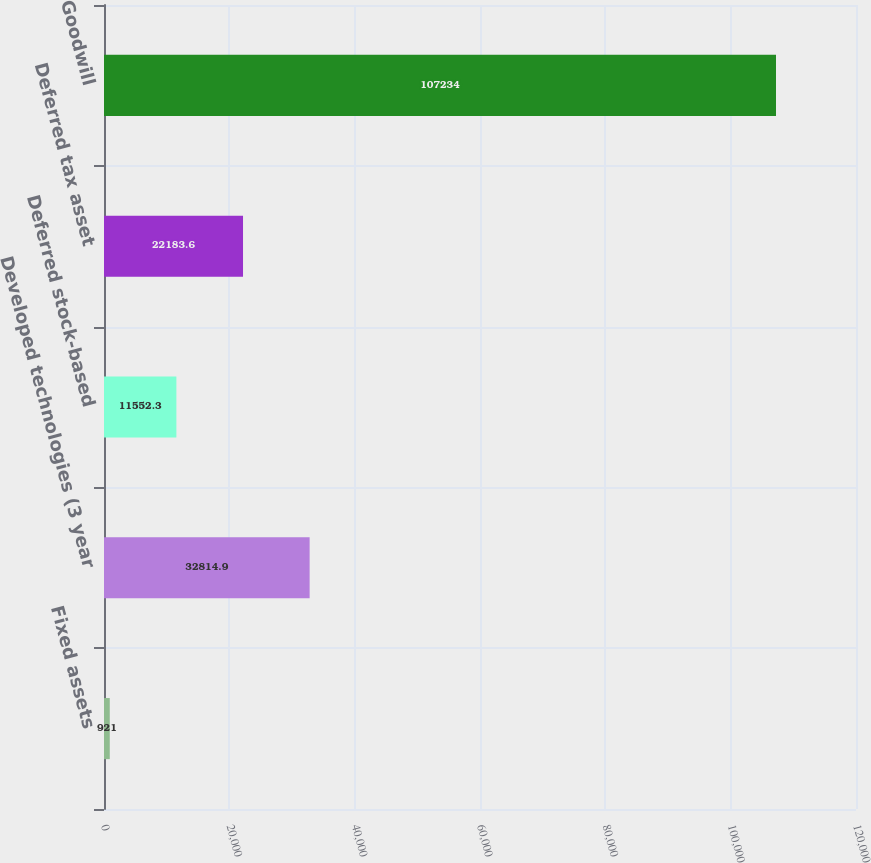<chart> <loc_0><loc_0><loc_500><loc_500><bar_chart><fcel>Fixed assets<fcel>Developed technologies (3 year<fcel>Deferred stock-based<fcel>Deferred tax asset<fcel>Goodwill<nl><fcel>921<fcel>32814.9<fcel>11552.3<fcel>22183.6<fcel>107234<nl></chart> 